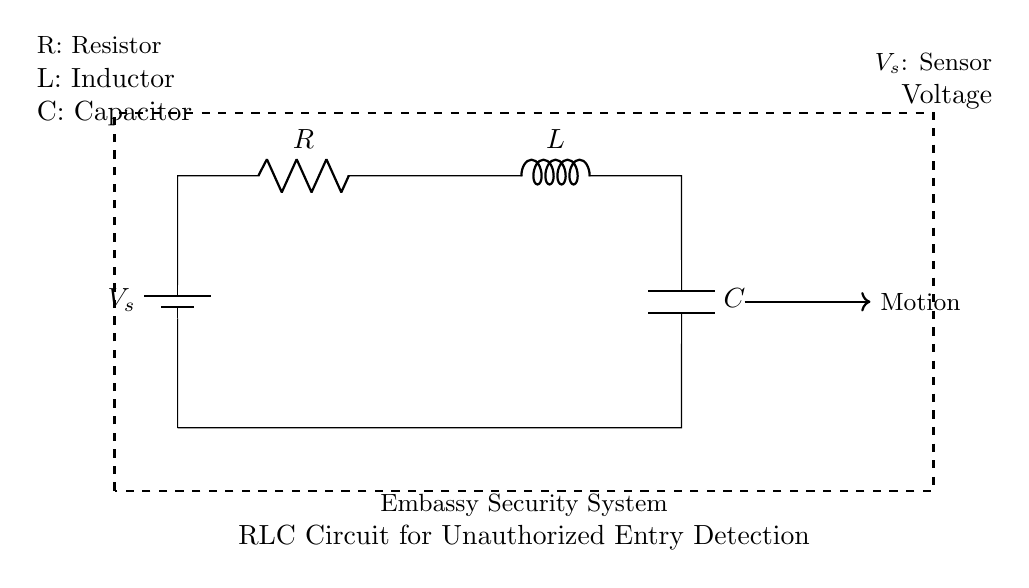What is the total number of components in this circuit? The circuit diagram shows a battery, a resistor, an inductor, and a capacitor. Adding these together gives a total of four components.
Answer: Four What is the function of the resistor in this circuit? The resistor limits the current flow in the circuit and helps to protect the other components from excess current, contributing to the overall stability of the circuit.
Answer: Limit current What type of circuit is being represented here? The circuit diagram features a combination of a resistor, inductor, and capacitor arranged in series, which is characteristic of an RLC circuit.
Answer: RLC circuit What is the purpose of the capacitor in this circuit? The capacitor stores electrical energy and releases it, which can help in smoothing out variations in voltage across the circuit, essential for detecting unauthorized entry.
Answer: Store energy How does the inductor contribute to the circuit functionality? The inductor resists changes in current flow and can help smooth out current fluctuations, which is critical in maintaining stable operation in security applications.
Answer: Resists current change What is the source of voltage in this circuit? The voltage source in this circuit is represented by the battery symbol, which provides the necessary electrical energy for the circuit operation.
Answer: Battery What role does the dashed rectangle play in the circuit diagram? The dashed rectangle indicates the boundary of the complete circuit, defining the area where the embassy security system operates, focusing on its components and functionality.
Answer: Define circuit area 